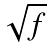Convert formula to latex. <formula><loc_0><loc_0><loc_500><loc_500>\sqrt { f }</formula> 